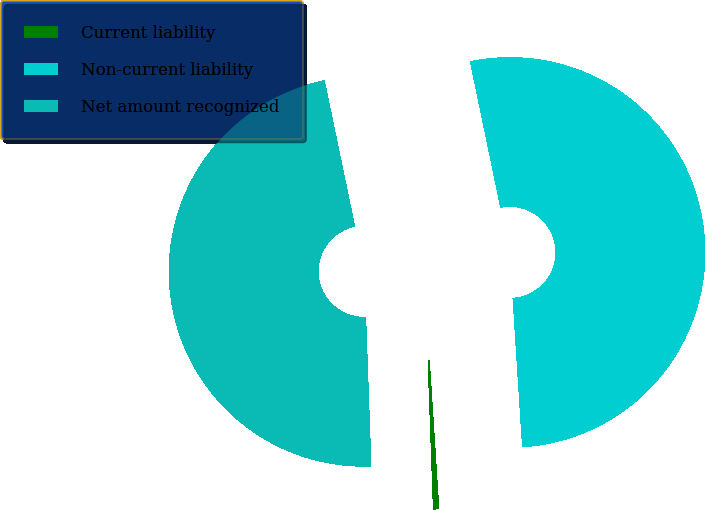<chart> <loc_0><loc_0><loc_500><loc_500><pie_chart><fcel>Current liability<fcel>Non-current liability<fcel>Net amount recognized<nl><fcel>0.45%<fcel>52.24%<fcel>47.3%<nl></chart> 